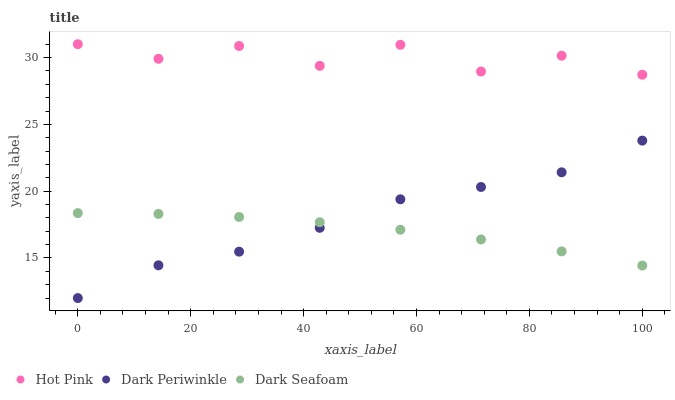Does Dark Seafoam have the minimum area under the curve?
Answer yes or no. Yes. Does Hot Pink have the maximum area under the curve?
Answer yes or no. Yes. Does Dark Periwinkle have the minimum area under the curve?
Answer yes or no. No. Does Dark Periwinkle have the maximum area under the curve?
Answer yes or no. No. Is Dark Seafoam the smoothest?
Answer yes or no. Yes. Is Hot Pink the roughest?
Answer yes or no. Yes. Is Dark Periwinkle the smoothest?
Answer yes or no. No. Is Dark Periwinkle the roughest?
Answer yes or no. No. Does Dark Periwinkle have the lowest value?
Answer yes or no. Yes. Does Hot Pink have the lowest value?
Answer yes or no. No. Does Hot Pink have the highest value?
Answer yes or no. Yes. Does Dark Periwinkle have the highest value?
Answer yes or no. No. Is Dark Seafoam less than Hot Pink?
Answer yes or no. Yes. Is Hot Pink greater than Dark Periwinkle?
Answer yes or no. Yes. Does Dark Periwinkle intersect Dark Seafoam?
Answer yes or no. Yes. Is Dark Periwinkle less than Dark Seafoam?
Answer yes or no. No. Is Dark Periwinkle greater than Dark Seafoam?
Answer yes or no. No. Does Dark Seafoam intersect Hot Pink?
Answer yes or no. No. 